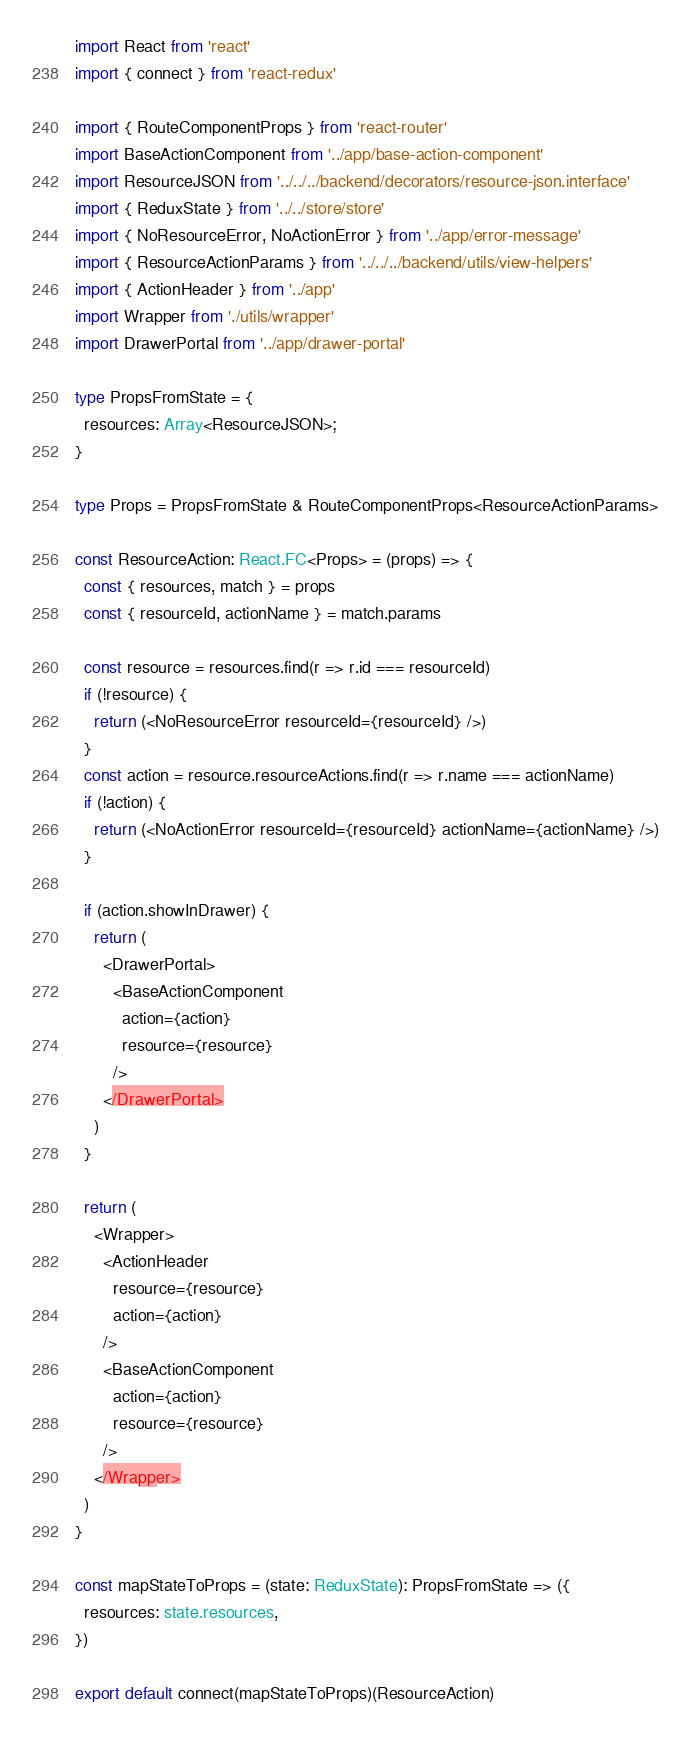<code> <loc_0><loc_0><loc_500><loc_500><_TypeScript_>import React from 'react'
import { connect } from 'react-redux'

import { RouteComponentProps } from 'react-router'
import BaseActionComponent from '../app/base-action-component'
import ResourceJSON from '../../../backend/decorators/resource-json.interface'
import { ReduxState } from '../../store/store'
import { NoResourceError, NoActionError } from '../app/error-message'
import { ResourceActionParams } from '../../../backend/utils/view-helpers'
import { ActionHeader } from '../app'
import Wrapper from './utils/wrapper'
import DrawerPortal from '../app/drawer-portal'

type PropsFromState = {
  resources: Array<ResourceJSON>;
}

type Props = PropsFromState & RouteComponentProps<ResourceActionParams>

const ResourceAction: React.FC<Props> = (props) => {
  const { resources, match } = props
  const { resourceId, actionName } = match.params

  const resource = resources.find(r => r.id === resourceId)
  if (!resource) {
    return (<NoResourceError resourceId={resourceId} />)
  }
  const action = resource.resourceActions.find(r => r.name === actionName)
  if (!action) {
    return (<NoActionError resourceId={resourceId} actionName={actionName} />)
  }

  if (action.showInDrawer) {
    return (
      <DrawerPortal>
        <BaseActionComponent
          action={action}
          resource={resource}
        />
      </DrawerPortal>
    )
  }

  return (
    <Wrapper>
      <ActionHeader
        resource={resource}
        action={action}
      />
      <BaseActionComponent
        action={action}
        resource={resource}
      />
    </Wrapper>
  )
}

const mapStateToProps = (state: ReduxState): PropsFromState => ({
  resources: state.resources,
})

export default connect(mapStateToProps)(ResourceAction)
</code> 